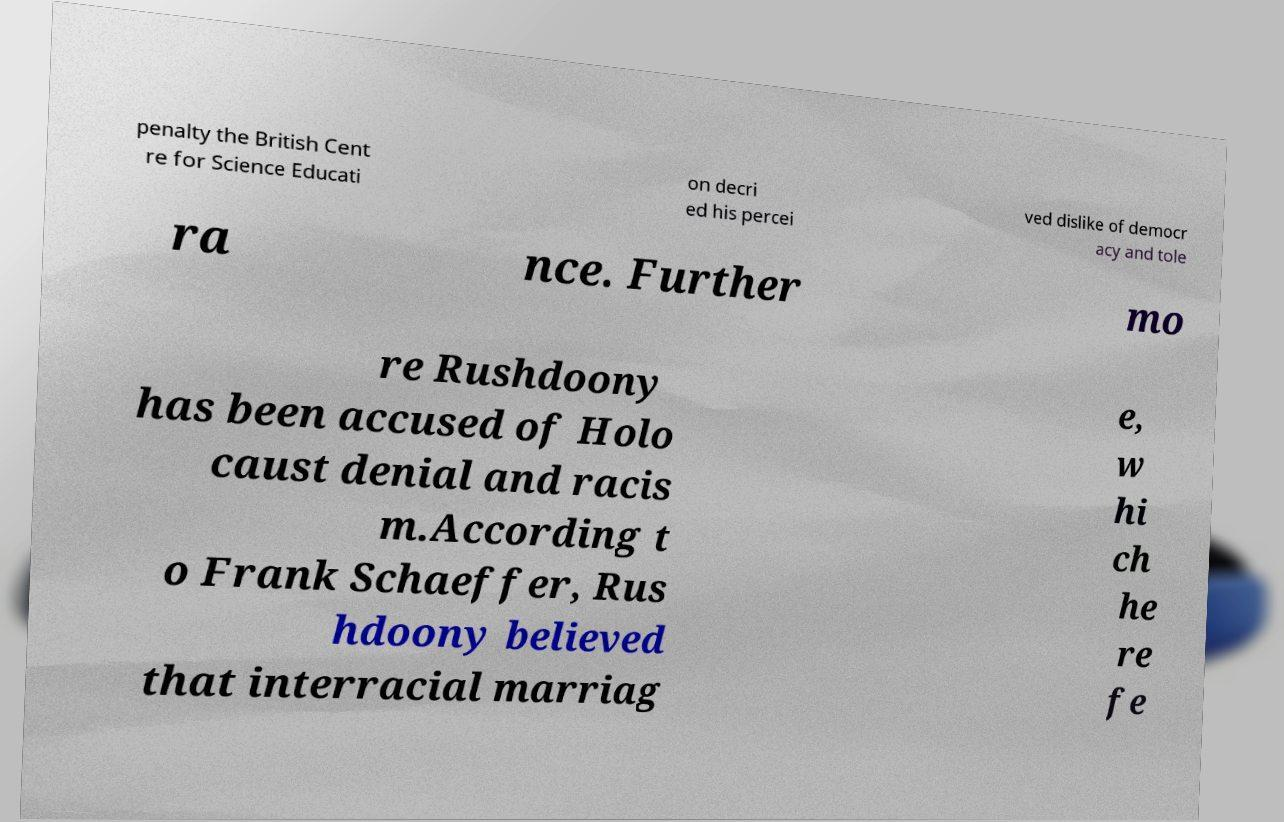Can you read and provide the text displayed in the image?This photo seems to have some interesting text. Can you extract and type it out for me? penalty the British Cent re for Science Educati on decri ed his percei ved dislike of democr acy and tole ra nce. Further mo re Rushdoony has been accused of Holo caust denial and racis m.According t o Frank Schaeffer, Rus hdoony believed that interracial marriag e, w hi ch he re fe 